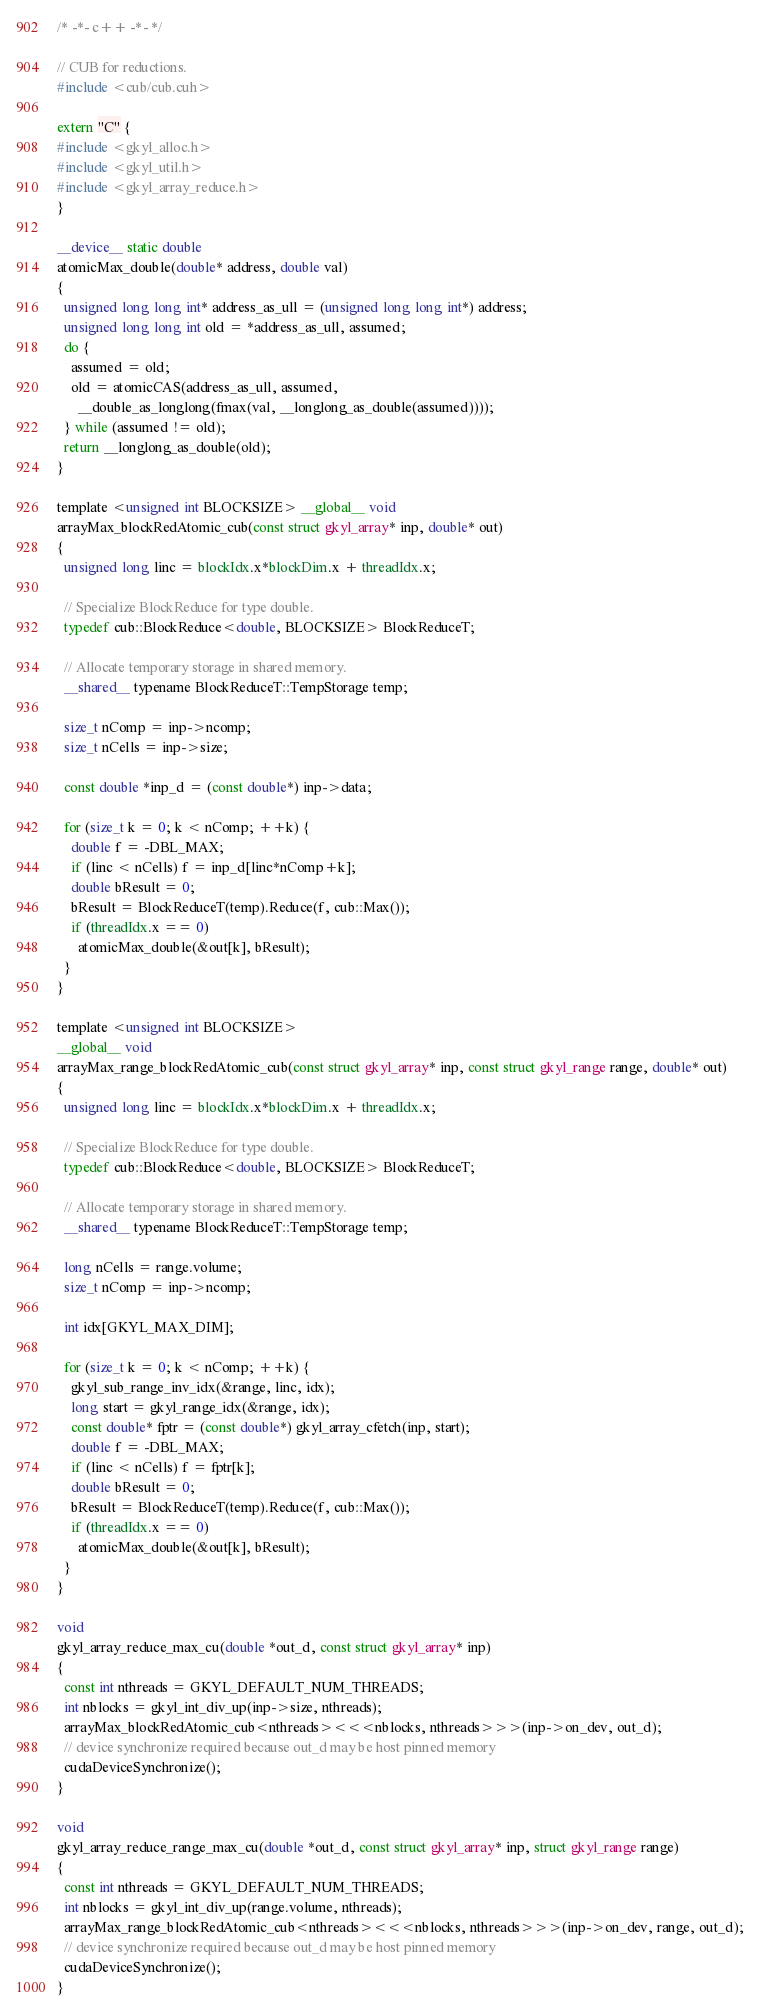<code> <loc_0><loc_0><loc_500><loc_500><_Cuda_>/* -*- c++ -*- */

// CUB for reductions.
#include <cub/cub.cuh>

extern "C" {
#include <gkyl_alloc.h>
#include <gkyl_util.h>
#include <gkyl_array_reduce.h>
}

__device__ static double
atomicMax_double(double* address, double val)
{
  unsigned long long int* address_as_ull = (unsigned long long int*) address;
  unsigned long long int old = *address_as_ull, assumed;
  do {
    assumed = old;
    old = atomicCAS(address_as_ull, assumed,
      __double_as_longlong(fmax(val, __longlong_as_double(assumed))));
  } while (assumed != old);
  return __longlong_as_double(old);
}

template <unsigned int BLOCKSIZE> __global__ void
arrayMax_blockRedAtomic_cub(const struct gkyl_array* inp, double* out)
{
  unsigned long linc = blockIdx.x*blockDim.x + threadIdx.x;

  // Specialize BlockReduce for type double.
  typedef cub::BlockReduce<double, BLOCKSIZE> BlockReduceT;

  // Allocate temporary storage in shared memory.
  __shared__ typename BlockReduceT::TempStorage temp;

  size_t nComp = inp->ncomp;
  size_t nCells = inp->size;

  const double *inp_d = (const double*) inp->data;

  for (size_t k = 0; k < nComp; ++k) {
    double f = -DBL_MAX;
    if (linc < nCells) f = inp_d[linc*nComp+k];
    double bResult = 0;
    bResult = BlockReduceT(temp).Reduce(f, cub::Max());
    if (threadIdx.x == 0)
      atomicMax_double(&out[k], bResult);
  }
}

template <unsigned int BLOCKSIZE>
__global__ void
arrayMax_range_blockRedAtomic_cub(const struct gkyl_array* inp, const struct gkyl_range range, double* out)
{
  unsigned long linc = blockIdx.x*blockDim.x + threadIdx.x;

  // Specialize BlockReduce for type double.
  typedef cub::BlockReduce<double, BLOCKSIZE> BlockReduceT;

  // Allocate temporary storage in shared memory.
  __shared__ typename BlockReduceT::TempStorage temp;

  long nCells = range.volume;
  size_t nComp = inp->ncomp;

  int idx[GKYL_MAX_DIM];

  for (size_t k = 0; k < nComp; ++k) {
    gkyl_sub_range_inv_idx(&range, linc, idx);
    long start = gkyl_range_idx(&range, idx);
    const double* fptr = (const double*) gkyl_array_cfetch(inp, start);
    double f = -DBL_MAX;
    if (linc < nCells) f = fptr[k];
    double bResult = 0;
    bResult = BlockReduceT(temp).Reduce(f, cub::Max());
    if (threadIdx.x == 0)
      atomicMax_double(&out[k], bResult);
  }
}

void
gkyl_array_reduce_max_cu(double *out_d, const struct gkyl_array* inp)
{
  const int nthreads = GKYL_DEFAULT_NUM_THREADS;  
  int nblocks = gkyl_int_div_up(inp->size, nthreads);
  arrayMax_blockRedAtomic_cub<nthreads><<<nblocks, nthreads>>>(inp->on_dev, out_d);
  // device synchronize required because out_d may be host pinned memory
  cudaDeviceSynchronize();
}

void
gkyl_array_reduce_range_max_cu(double *out_d, const struct gkyl_array* inp, struct gkyl_range range)
{
  const int nthreads = GKYL_DEFAULT_NUM_THREADS;
  int nblocks = gkyl_int_div_up(range.volume, nthreads);
  arrayMax_range_blockRedAtomic_cub<nthreads><<<nblocks, nthreads>>>(inp->on_dev, range, out_d);
  // device synchronize required because out_d may be host pinned memory
  cudaDeviceSynchronize();
}
</code> 